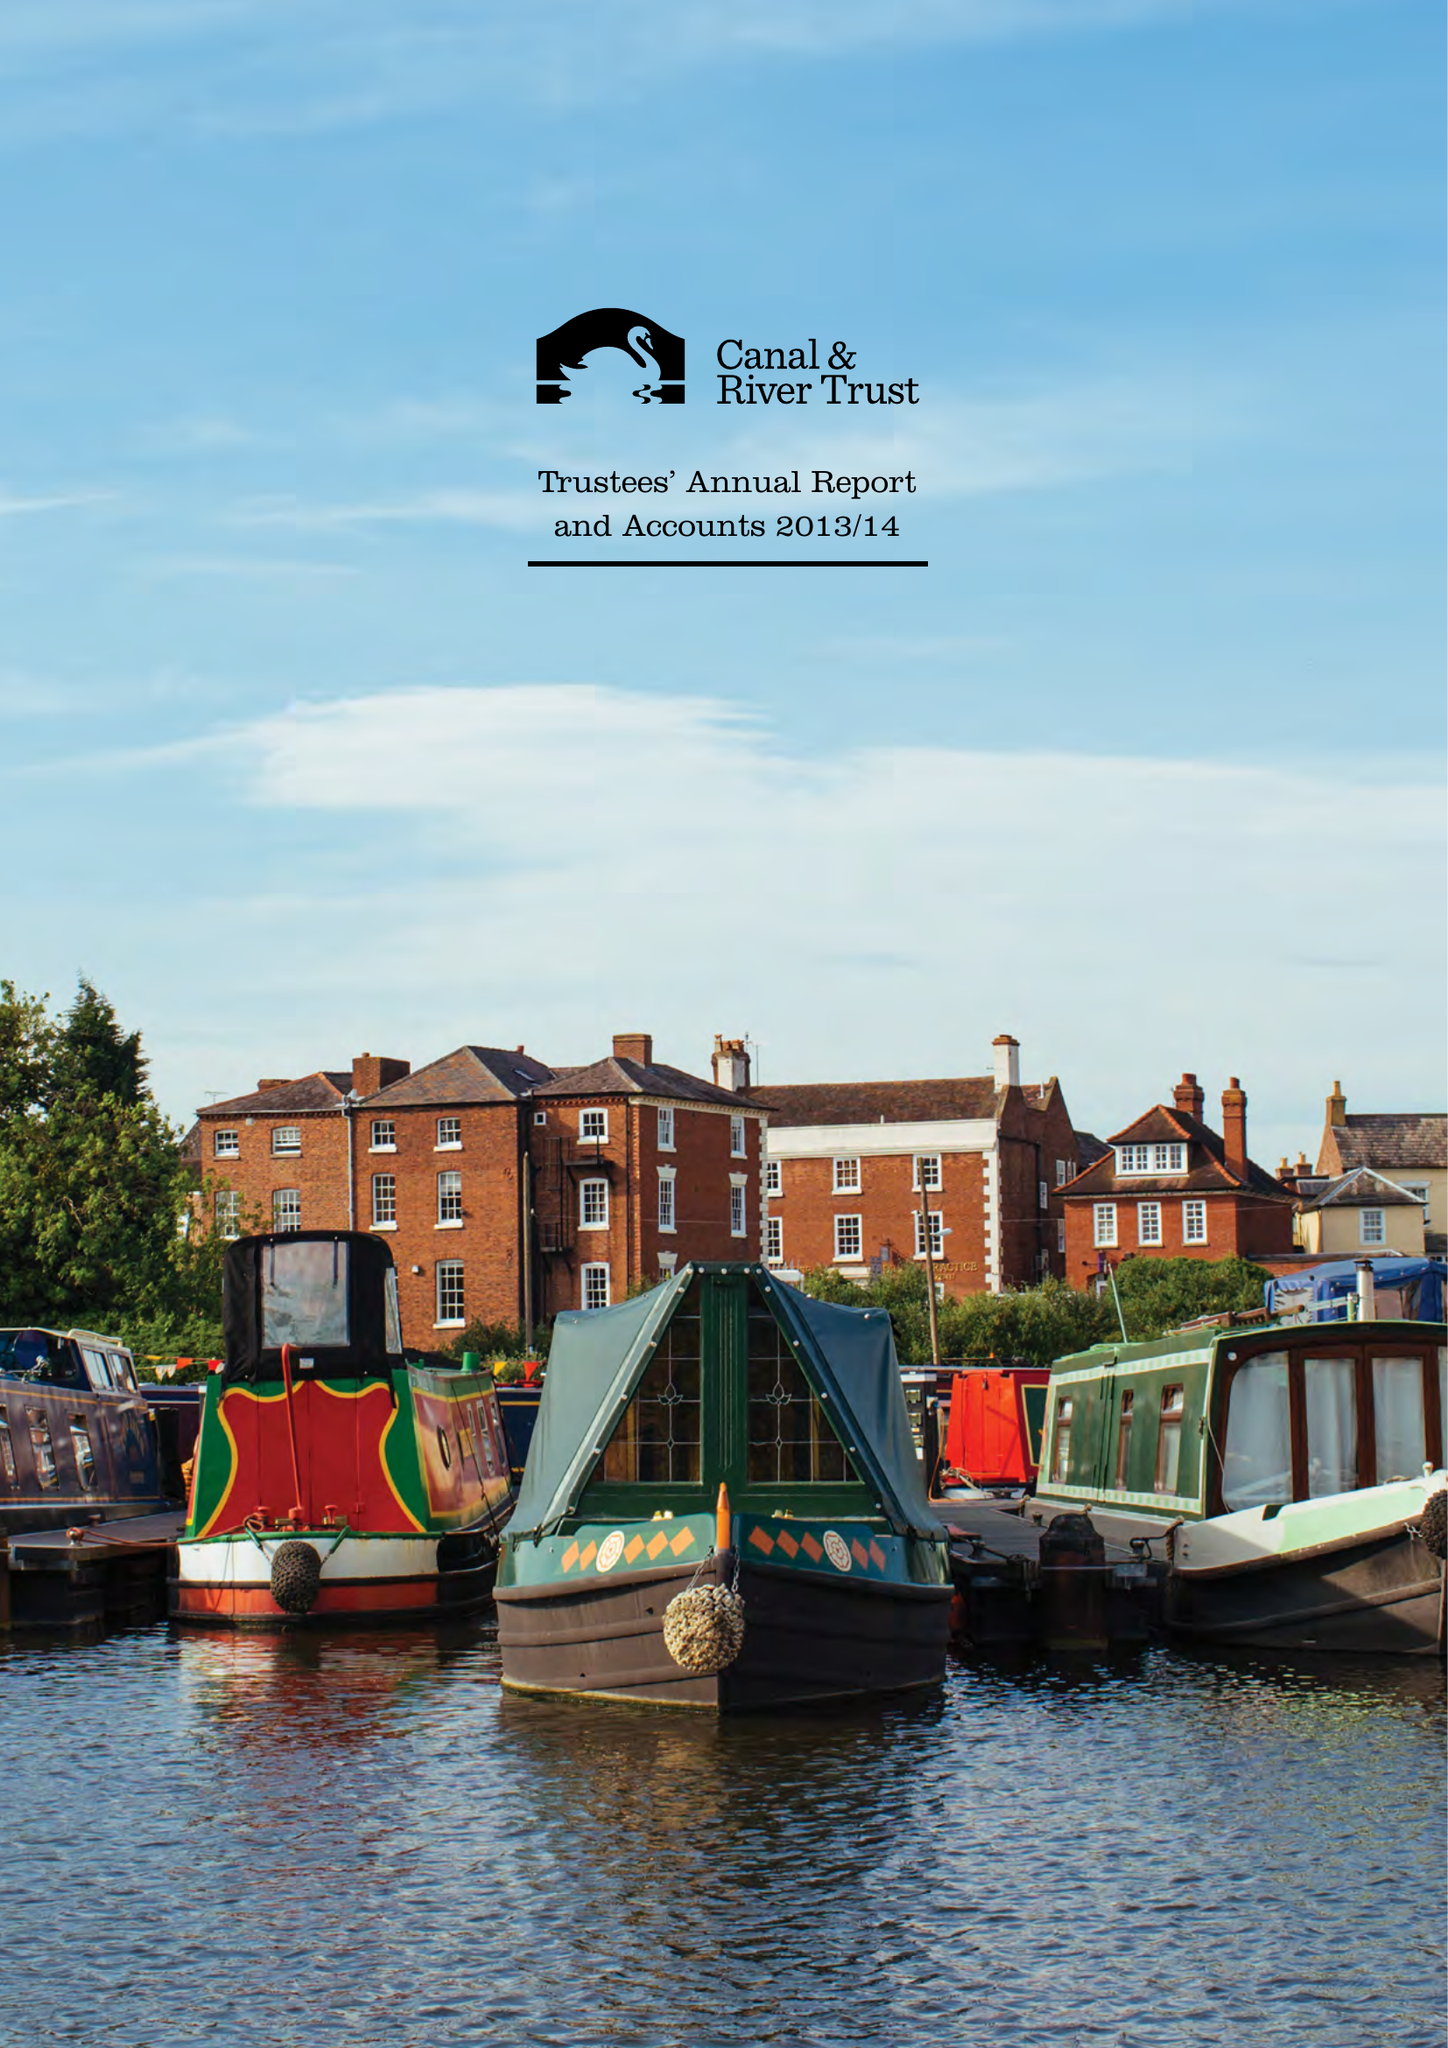What is the value for the report_date?
Answer the question using a single word or phrase. 2014-03-31 